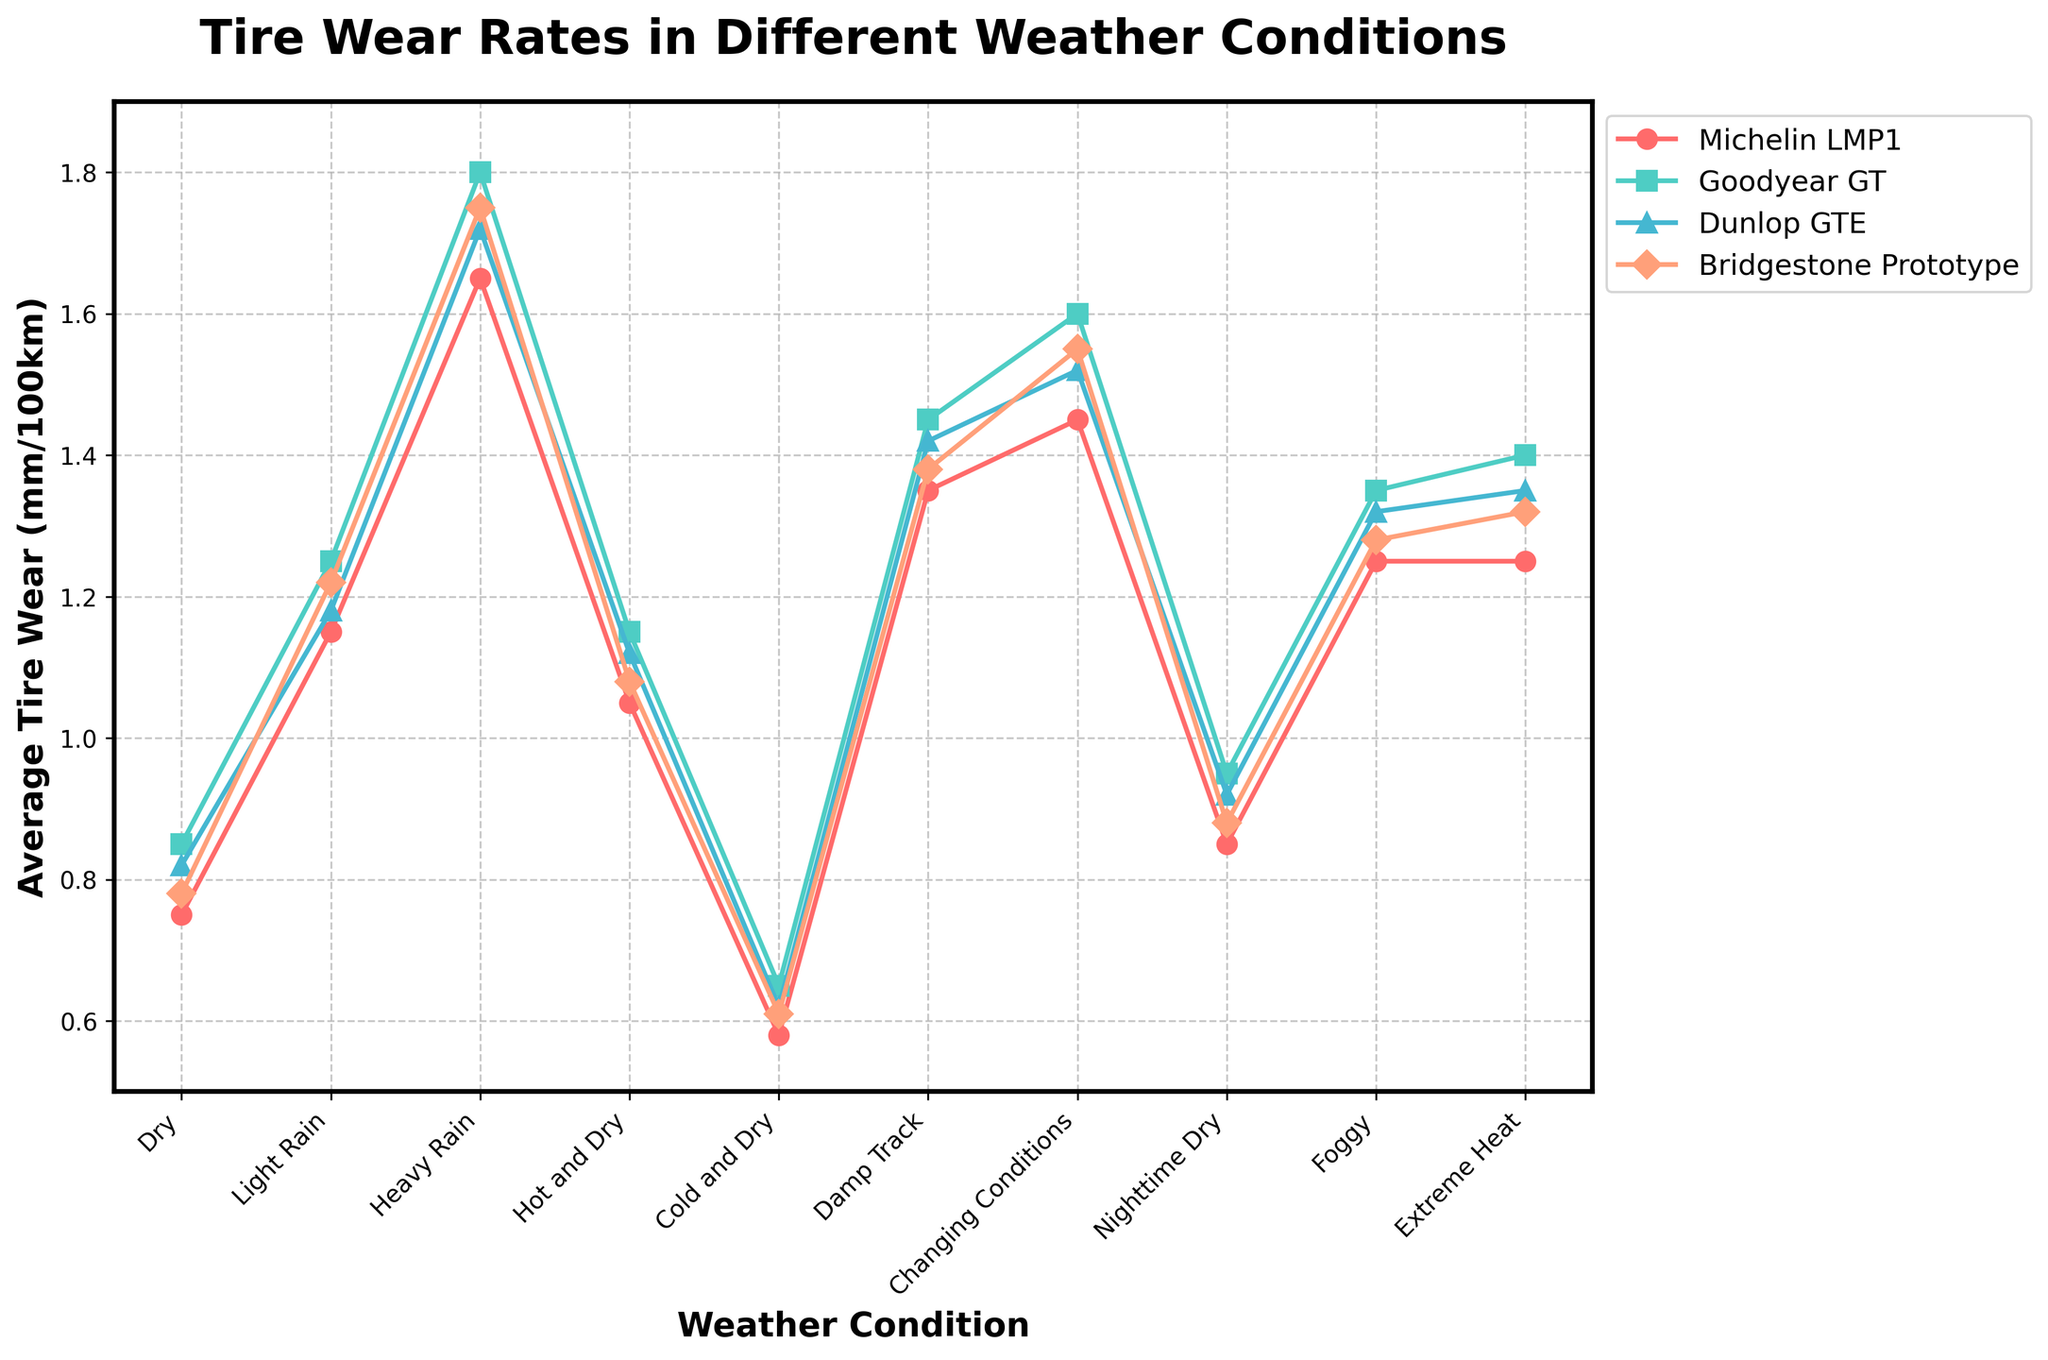Which weather condition shows the highest tire wear rate for Michelin LMP1? Identify the line associated with Michelin LMP1 and locate the highest data point on that line. Michelin LMP1 reaches its peak wear rate under Heavy Rain conditions.
Answer: Heavy Rain How does the tire wear rate for Goodyear GT in Dry conditions compare to Bridgestone Prototype in the same conditions? Find the points corresponding to Dry conditions for both Goodyear GT and Bridgestone Prototype. Goodyear GT's wear rate is 0.85 mm/100km, while Bridgestone Prototype's is 0.78 mm/100km, meaning Goodyear GT's rate is higher.
Answer: Goodyear GT's rate is higher What is the average tire wear rate across all weather conditions for Dunlop GTE? Add the tire wear rates for Dunlop GTE across all weather conditions and divide by the number of conditions (10). (0.82 + 1.18 + 1.72 + 1.12 + 0.62 + 1.42 + 1.52 + 0.92 + 1.32 + 1.35) / 10 = 1.199 mm/100km
Answer: 1.199 mm/100km In which weather condition is the difference between the tire wear rates of Dunlop GTE and Michelin LMP1 the greatest? Calculate the differences between Dunlop GTE and Michelin LMP1 wear rates for each condition and identify the highest difference. For Heavy Rain, the difference is the greatest: 1.72 - 1.65 = 0.07 mm/100km.
Answer: Heavy Rain How does the tire wear rate for Michelin LMP1 in Cold and Dry conditions compare to its wear rate in Nighttime Dry conditions? Compare the data points for Cold and Dry (0.58 mm/100km) to Nighttime Dry (0.85 mm/100km) for Michelin LMP1. The wear rate is lower in Cold and Dry conditions.
Answer: Lower in Cold and Dry What is the total tire wear rate for Bridgestone Prototype in all rain-related conditions (Light Rain, Heavy Rain, Damp Track)? Sum the tire wear rates for Bridgestone Prototype in Light Rain (1.22), Heavy Rain (1.75), and Damp Track (1.38): 1.22 + 1.75 + 1.38 = 4.35 mm/100km.
Answer: 4.35 mm/100km Which brand shows the least fluctuation in tire wear rate across different weather conditions, and what is the range of their wear rates? Determine the range of tire wear rates for each brand by finding the difference between their highest and lowest wear rates, and identify the one with the smallest range. Michelin LMP1 has the least fluctuation with a range of 1.65 - 0.58 = 1.07 mm/100km.
Answer: Michelin LMP1, range 1.07 mm/100km During which weather condition do all tire brands have their lowest wear rates? Identify the weather condition where all brands depict their minimum wear rates on the chart. All brands exhibit their lowest wear rates in Cold and Dry conditions.
Answer: Cold and Dry 